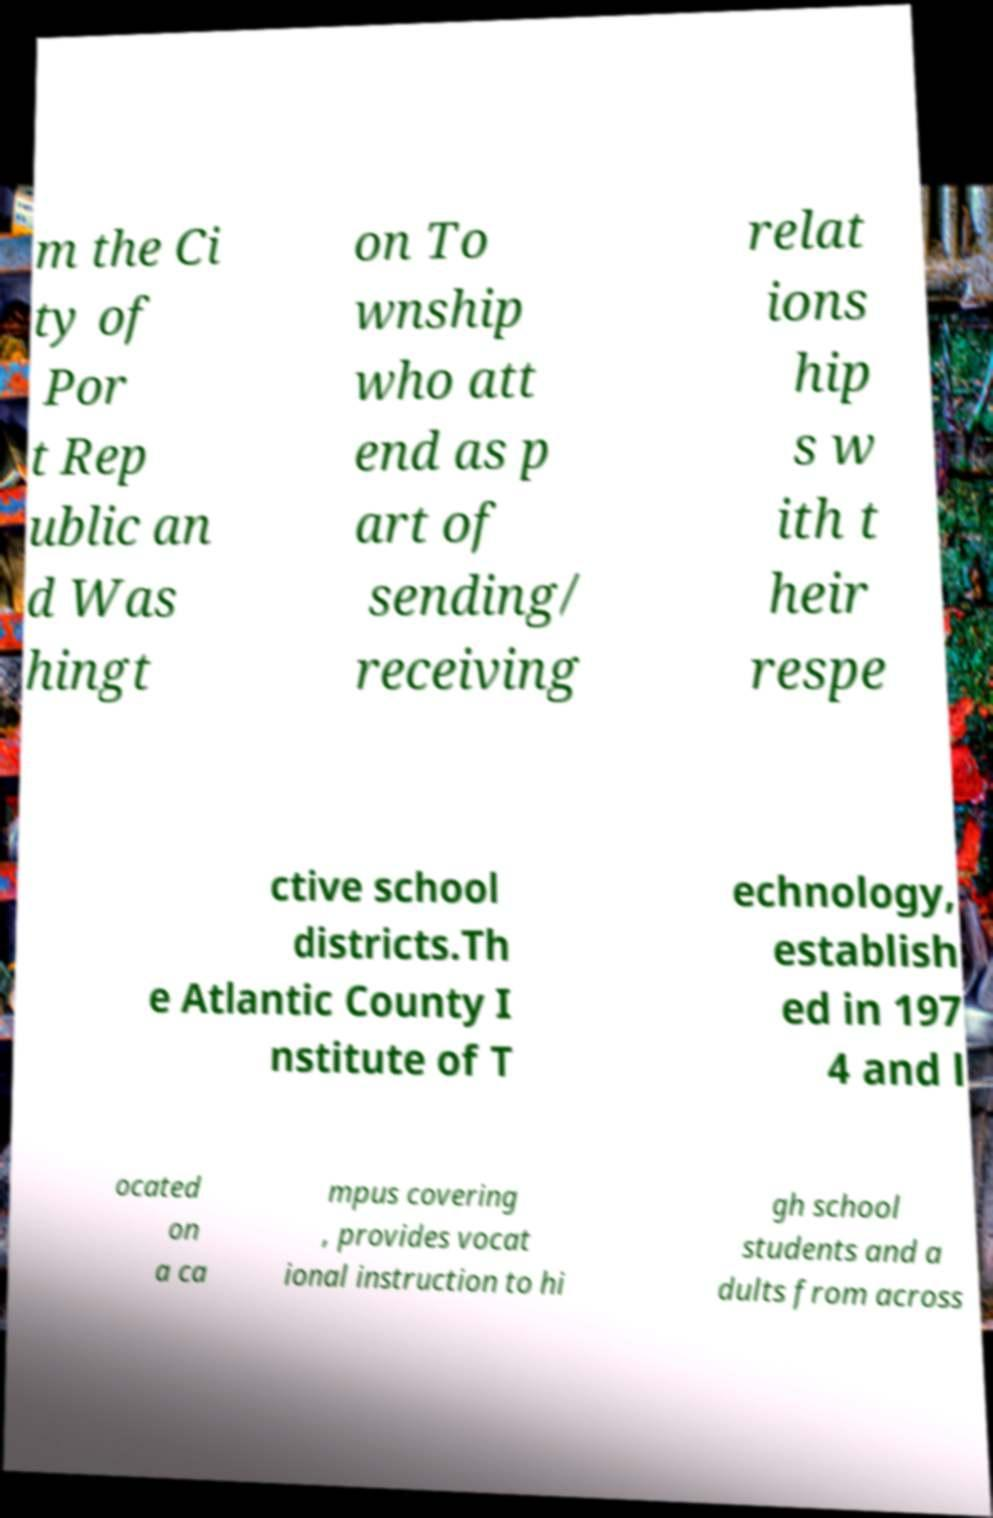Can you accurately transcribe the text from the provided image for me? m the Ci ty of Por t Rep ublic an d Was hingt on To wnship who att end as p art of sending/ receiving relat ions hip s w ith t heir respe ctive school districts.Th e Atlantic County I nstitute of T echnology, establish ed in 197 4 and l ocated on a ca mpus covering , provides vocat ional instruction to hi gh school students and a dults from across 